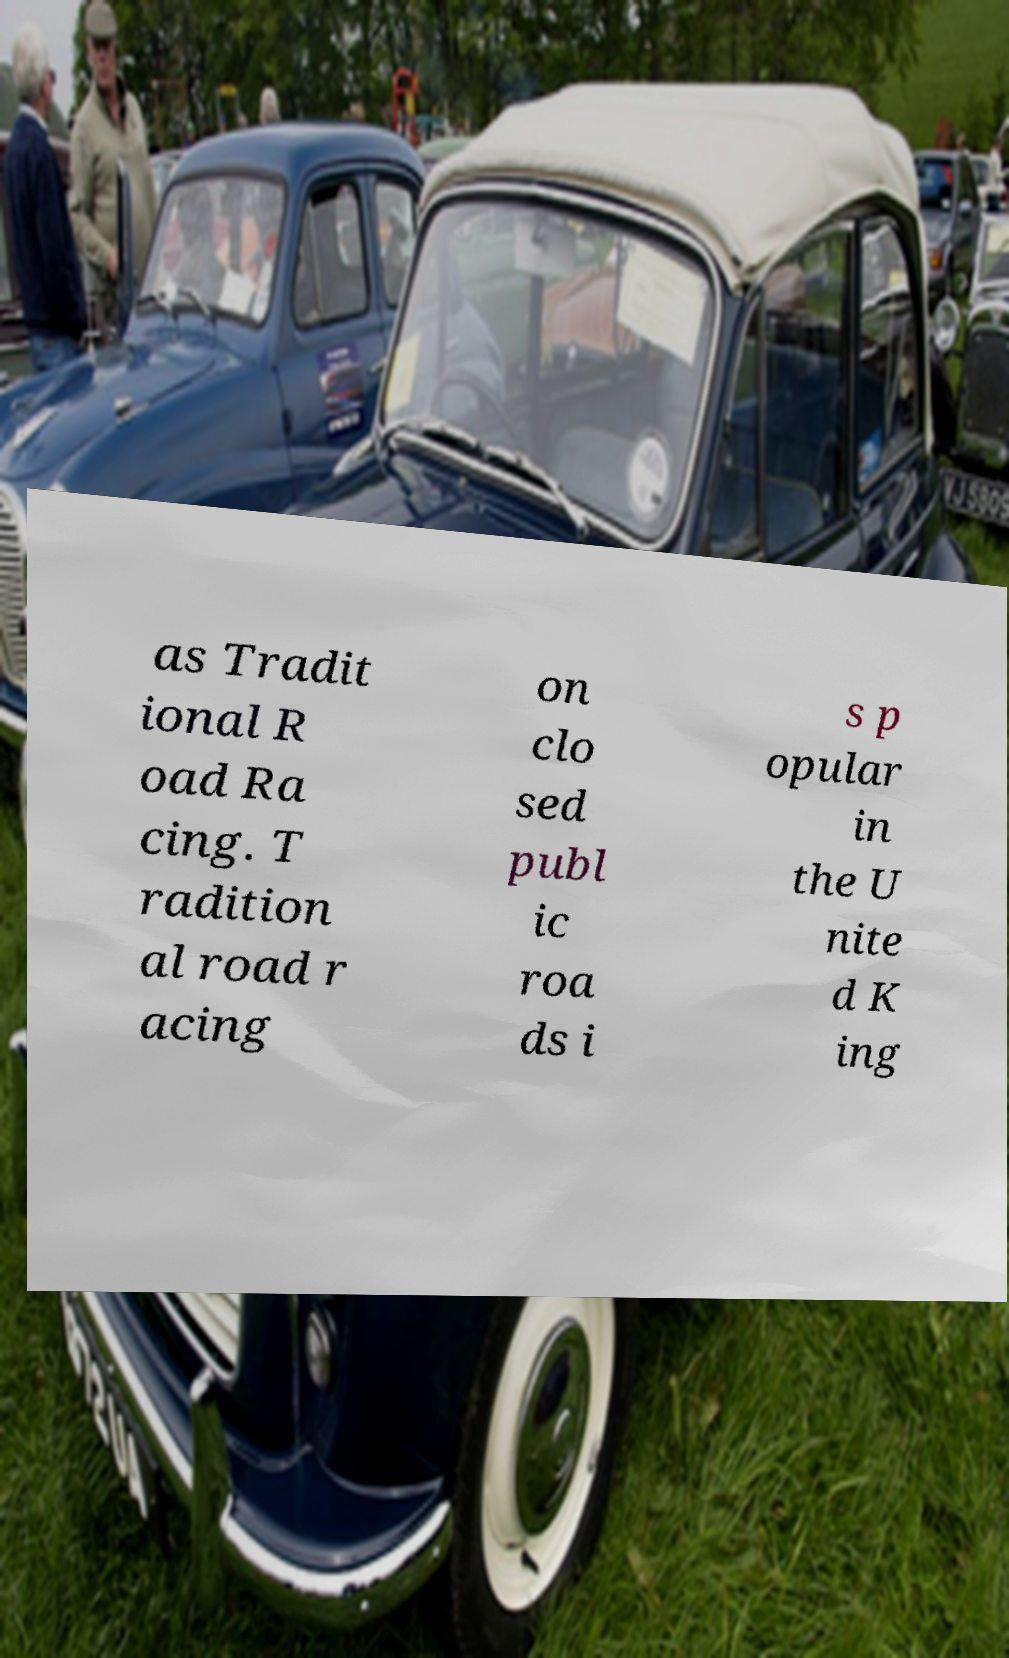There's text embedded in this image that I need extracted. Can you transcribe it verbatim? as Tradit ional R oad Ra cing. T radition al road r acing on clo sed publ ic roa ds i s p opular in the U nite d K ing 